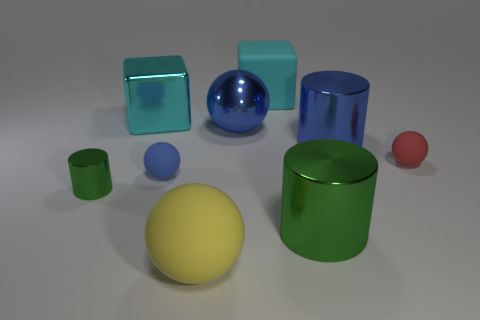What is the color of the other big thing that is the same shape as the large green thing?
Offer a very short reply. Blue. What is the shape of the green metal thing in front of the green metal thing left of the big blue object behind the blue metal cylinder?
Your response must be concise. Cylinder. There is a shiny thing that is right of the small green metallic cylinder and in front of the red rubber object; what size is it?
Provide a short and direct response. Large. Is the number of big cyan matte things less than the number of blue balls?
Your response must be concise. Yes. What size is the matte block that is to the right of the shiny ball?
Keep it short and to the point. Large. What shape is the metallic object that is both on the left side of the metal sphere and behind the big blue metal cylinder?
Provide a succinct answer. Cube. There is a red thing that is the same shape as the large yellow thing; what is its size?
Provide a succinct answer. Small. How many big cyan things have the same material as the blue cylinder?
Ensure brevity in your answer.  1. Is the color of the metallic block the same as the rubber sphere that is behind the small blue sphere?
Keep it short and to the point. No. Is the number of tiny red balls greater than the number of big green blocks?
Your response must be concise. Yes. 